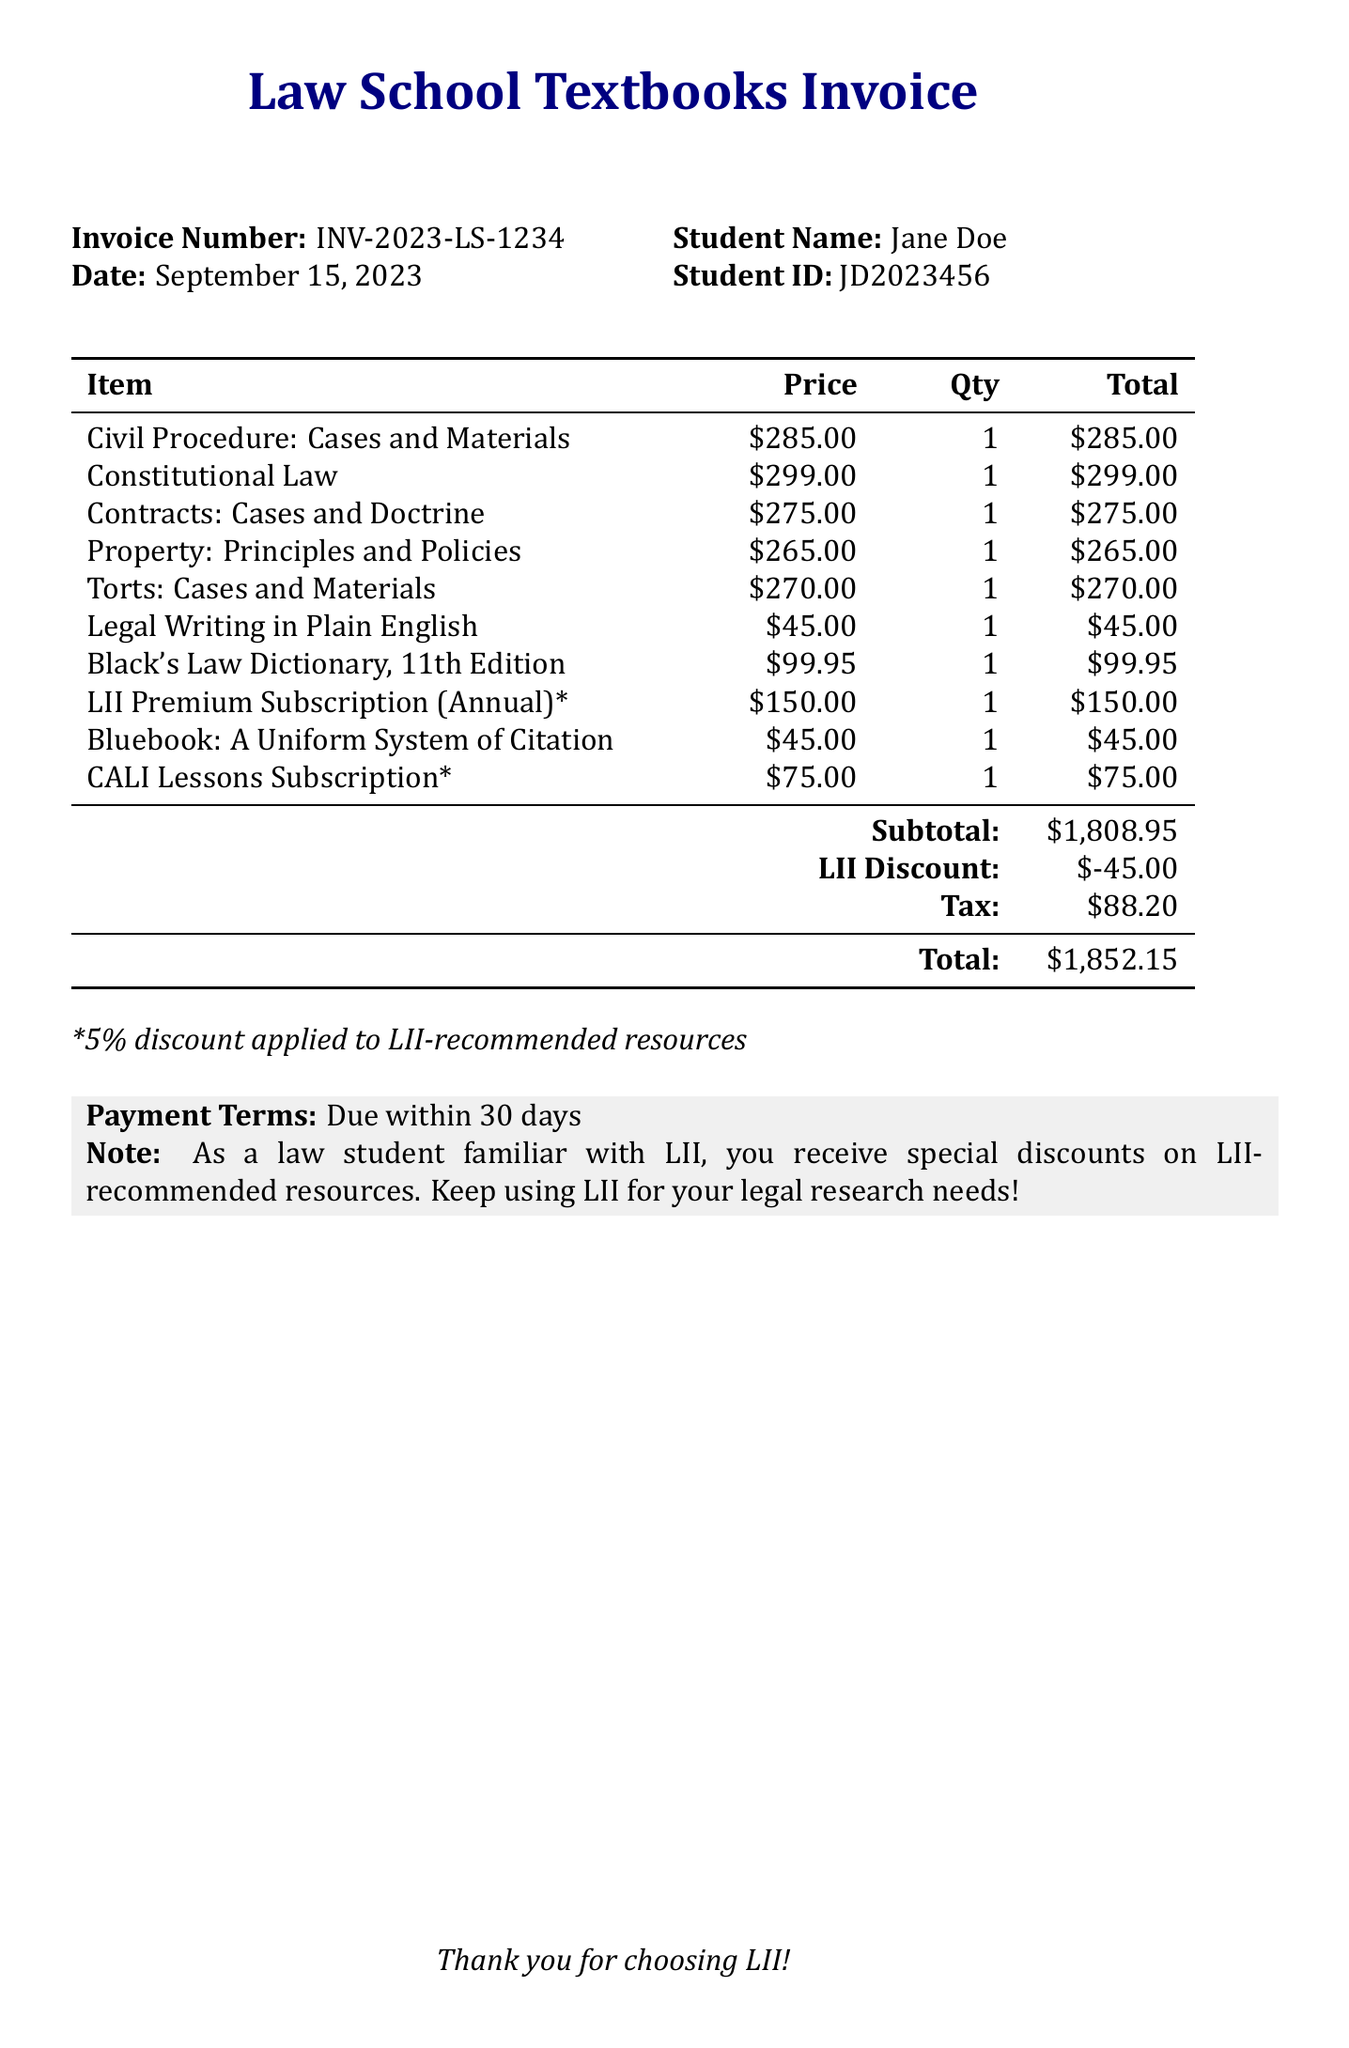what is the invoice number? The invoice number is clearly stated at the top of the document.
Answer: INV-2023-LS-1234 who is the student? The document lists the name of the student on the invoice.
Answer: Jane Doe what is the total amount due? The total is calculated at the bottom of the invoice after discounts and tax.
Answer: $1807.15 how many items are listed in the invoice? The invoice details a list of various textbooks and materials, and the number of items can be counted.
Answer: 10 what discount was applied for the LII-recommended resources? The discount applied to LII-recommended resources is mentioned in the notes of the invoice.
Answer: $45.00 when is the payment due? The payment terms specify when payment is required.
Answer: Due within 30 days what resource has a price of $150.00? The specific item priced at $150.00 is listed in the invoice.
Answer: LII Premium Subscription (Annual) which publisher released "Black's Law Dictionary, 11th Edition"? The publisher of this item is clearly identified in the invoice.
Answer: Thomson West how much tax was added to the total? The tax amount is specified in the financial summary at the end of the document.
Answer: $88.20 what is the subtotal before any discounts? The subtotal reflects the total of all items listed before discounts are applied.
Answer: $1763.95 